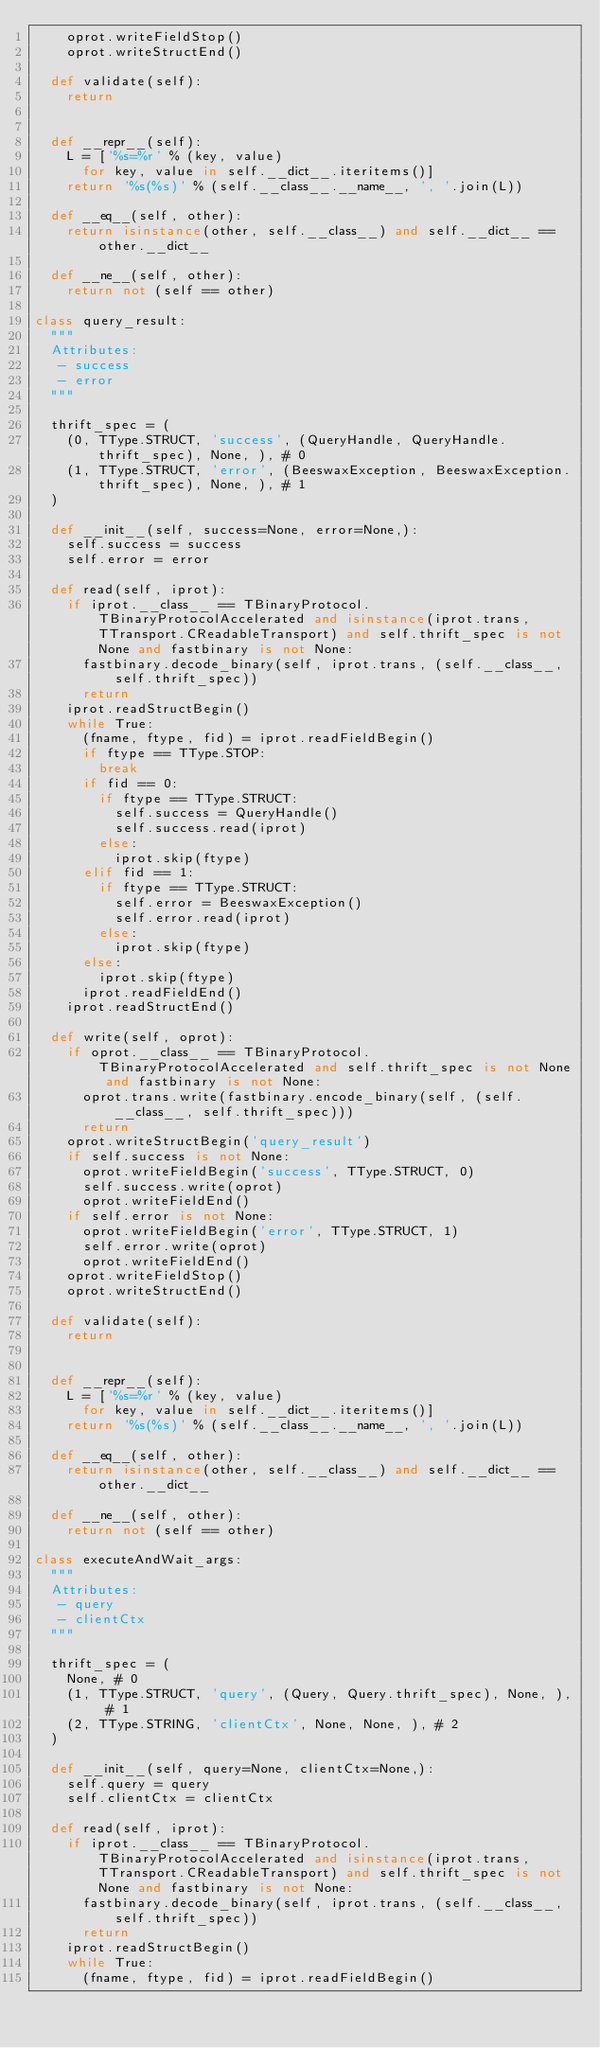Convert code to text. <code><loc_0><loc_0><loc_500><loc_500><_Python_>    oprot.writeFieldStop()
    oprot.writeStructEnd()

  def validate(self):
    return


  def __repr__(self):
    L = ['%s=%r' % (key, value)
      for key, value in self.__dict__.iteritems()]
    return '%s(%s)' % (self.__class__.__name__, ', '.join(L))

  def __eq__(self, other):
    return isinstance(other, self.__class__) and self.__dict__ == other.__dict__

  def __ne__(self, other):
    return not (self == other)

class query_result:
  """
  Attributes:
   - success
   - error
  """

  thrift_spec = (
    (0, TType.STRUCT, 'success', (QueryHandle, QueryHandle.thrift_spec), None, ), # 0
    (1, TType.STRUCT, 'error', (BeeswaxException, BeeswaxException.thrift_spec), None, ), # 1
  )

  def __init__(self, success=None, error=None,):
    self.success = success
    self.error = error

  def read(self, iprot):
    if iprot.__class__ == TBinaryProtocol.TBinaryProtocolAccelerated and isinstance(iprot.trans, TTransport.CReadableTransport) and self.thrift_spec is not None and fastbinary is not None:
      fastbinary.decode_binary(self, iprot.trans, (self.__class__, self.thrift_spec))
      return
    iprot.readStructBegin()
    while True:
      (fname, ftype, fid) = iprot.readFieldBegin()
      if ftype == TType.STOP:
        break
      if fid == 0:
        if ftype == TType.STRUCT:
          self.success = QueryHandle()
          self.success.read(iprot)
        else:
          iprot.skip(ftype)
      elif fid == 1:
        if ftype == TType.STRUCT:
          self.error = BeeswaxException()
          self.error.read(iprot)
        else:
          iprot.skip(ftype)
      else:
        iprot.skip(ftype)
      iprot.readFieldEnd()
    iprot.readStructEnd()

  def write(self, oprot):
    if oprot.__class__ == TBinaryProtocol.TBinaryProtocolAccelerated and self.thrift_spec is not None and fastbinary is not None:
      oprot.trans.write(fastbinary.encode_binary(self, (self.__class__, self.thrift_spec)))
      return
    oprot.writeStructBegin('query_result')
    if self.success is not None:
      oprot.writeFieldBegin('success', TType.STRUCT, 0)
      self.success.write(oprot)
      oprot.writeFieldEnd()
    if self.error is not None:
      oprot.writeFieldBegin('error', TType.STRUCT, 1)
      self.error.write(oprot)
      oprot.writeFieldEnd()
    oprot.writeFieldStop()
    oprot.writeStructEnd()

  def validate(self):
    return


  def __repr__(self):
    L = ['%s=%r' % (key, value)
      for key, value in self.__dict__.iteritems()]
    return '%s(%s)' % (self.__class__.__name__, ', '.join(L))

  def __eq__(self, other):
    return isinstance(other, self.__class__) and self.__dict__ == other.__dict__

  def __ne__(self, other):
    return not (self == other)

class executeAndWait_args:
  """
  Attributes:
   - query
   - clientCtx
  """

  thrift_spec = (
    None, # 0
    (1, TType.STRUCT, 'query', (Query, Query.thrift_spec), None, ), # 1
    (2, TType.STRING, 'clientCtx', None, None, ), # 2
  )

  def __init__(self, query=None, clientCtx=None,):
    self.query = query
    self.clientCtx = clientCtx

  def read(self, iprot):
    if iprot.__class__ == TBinaryProtocol.TBinaryProtocolAccelerated and isinstance(iprot.trans, TTransport.CReadableTransport) and self.thrift_spec is not None and fastbinary is not None:
      fastbinary.decode_binary(self, iprot.trans, (self.__class__, self.thrift_spec))
      return
    iprot.readStructBegin()
    while True:
      (fname, ftype, fid) = iprot.readFieldBegin()</code> 